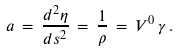<formula> <loc_0><loc_0><loc_500><loc_500>a \, = \, \frac { d ^ { 2 } \eta } { d s ^ { 2 } } \, = \, \frac { 1 } { \rho } \, = \, V ^ { 0 } \, \gamma \, .</formula> 